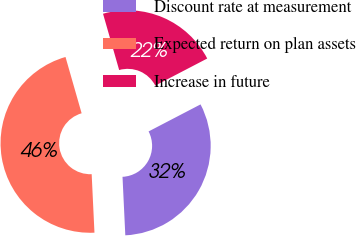<chart> <loc_0><loc_0><loc_500><loc_500><pie_chart><fcel>Discount rate at measurement<fcel>Expected return on plan assets<fcel>Increase in future<nl><fcel>31.88%<fcel>46.32%<fcel>21.8%<nl></chart> 